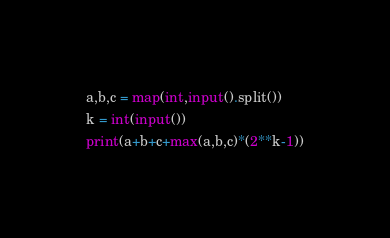<code> <loc_0><loc_0><loc_500><loc_500><_Python_>a,b,c = map(int,input().split())
k = int(input())
print(a+b+c+max(a,b,c)*(2**k-1))</code> 